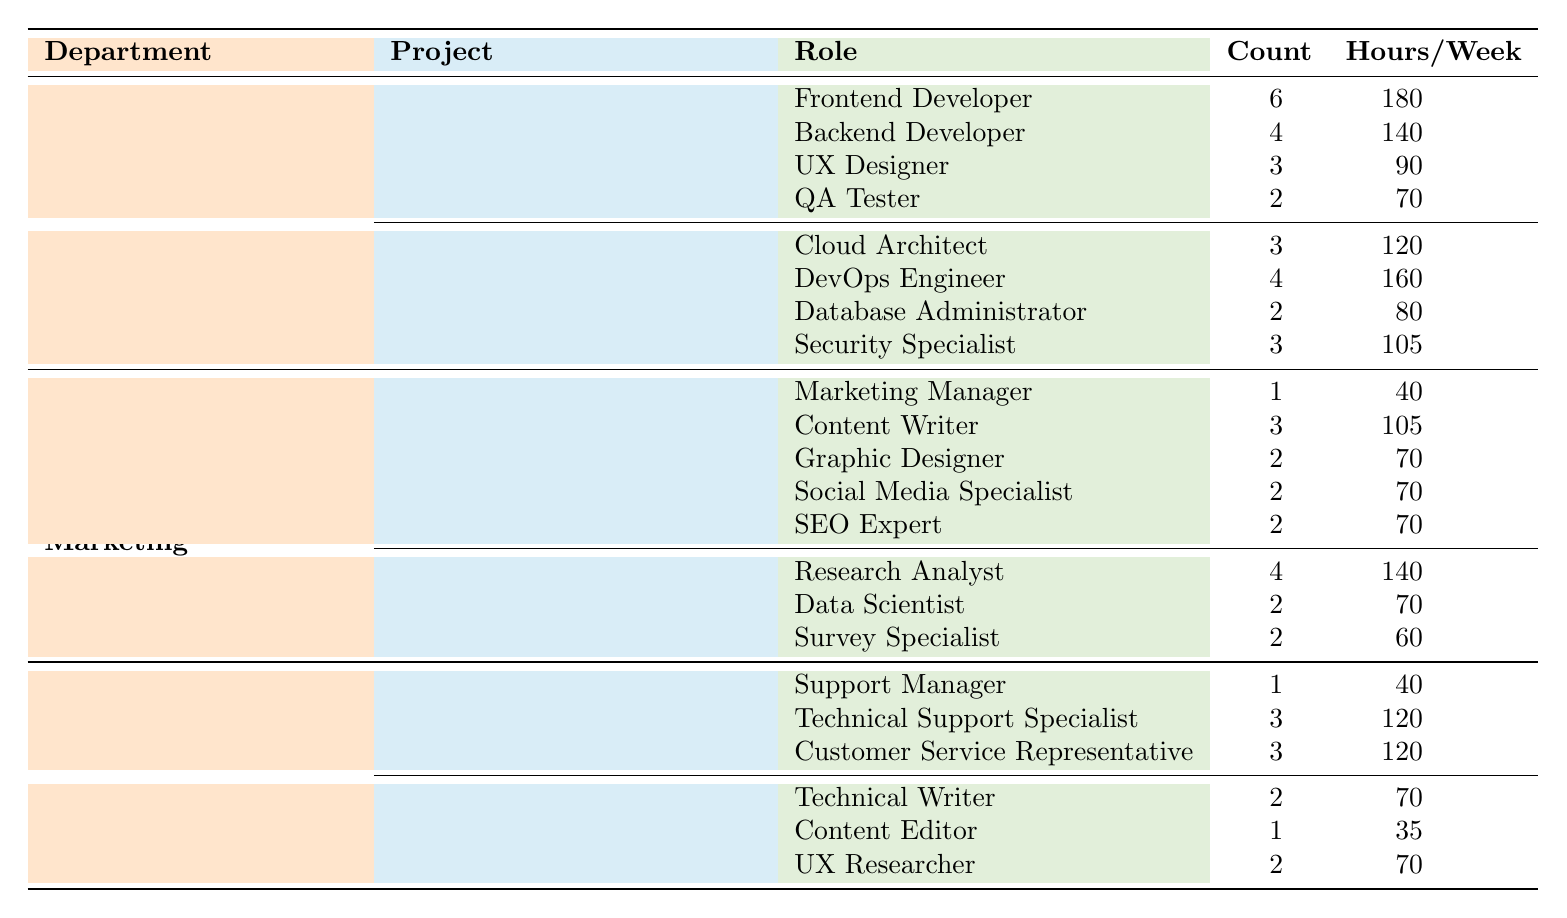What is the total number of resources allocated to the "Cloud Migration" project? From the table, the "Cloud Migration" project shows that 12 resources are allocated.
Answer: 12 Which department has the highest total resources? The Software Development department has 45 total resources, which is higher than Marketing with 30 and Customer Support with 25.
Answer: Software Development What is the utilization rate of the "Market Research Study" project? The utilization rate for the "Market Research Study" project is 0.75, as indicated in the table.
Answer: 0.75 How many Frontend Developers are allocated to the "Mobile App Redesign" project? The table states that there are 6 Frontend Developers allocated to the project "Mobile App Redesign."
Answer: 6 Which project in the Marketing department has the highest utilization rate? "Product Launch Campaign" has a utilization rate of 0.88, which is higher than 0.75 for "Market Research Study."
Answer: Product Launch Campaign What is the average number of resources allocated to projects under the Customer Support department? There are two projects with 7 and 5 allocated resources, respectively. The average is (7 + 5) / 2 = 6.
Answer: 6 Is the count of Technical Support Specialists allocated to the "Call Center Upgrade" project greater than the count of UX Researchers in the "Knowledge Base Enhancement" project? There are 3 Technical Support Specialists and 2 UX Researchers, so 3 is greater than 2.
Answer: Yes How many total hours are allocated to the roles in the "Cloud Migration" project? The total hours are calculated as (3*120) + (4*160) + (2*80) + (3*105) = 360 + 640 + 160 + 315 = 1475 hours.
Answer: 1475 What percentage of total resources does the Marketing department allocate to the "Product Launch Campaign"? The Marketing department has 30 resources in total, with 10 allocated to the "Product Launch Campaign." The percentage is (10/30) * 100% = 33.33%.
Answer: 33.33% Which roles are involved in the "Knowledge Base Enhancement" project? The roles listed are Technical Writer, Content Editor, and UX Researcher.
Answer: Technical Writer, Content Editor, UX Researcher How does the total number of hours per week for roles in the "Mobile App Redesign" project compare to that of "Market Research Study"? For "Mobile App Redesign": 6*180 + 4*140 + 3*90 + 2*70 = 1080 + 560 + 270 + 140 = 2050. For "Market Research Study": 4*140 + 2*70 + 2*60 = 560 + 140 + 120 = 820. Since 2050 > 820, Mobile App Redesign has more hours.
Answer: Mobile App Redesign has more hours 